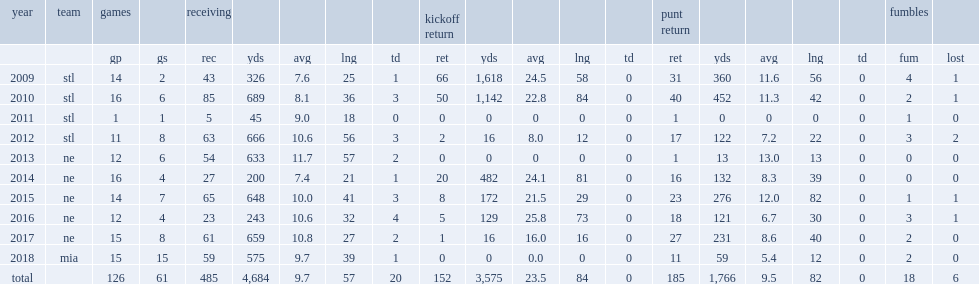In 2016, how many yards did amendola finish with? 129.0. I'm looking to parse the entire table for insights. Could you assist me with that? {'header': ['year', 'team', 'games', '', 'receiving', '', '', '', '', 'kickoff return', '', '', '', '', 'punt return', '', '', '', '', 'fumbles', ''], 'rows': [['', '', 'gp', 'gs', 'rec', 'yds', 'avg', 'lng', 'td', 'ret', 'yds', 'avg', 'lng', 'td', 'ret', 'yds', 'avg', 'lng', 'td', 'fum', 'lost'], ['2009', 'stl', '14', '2', '43', '326', '7.6', '25', '1', '66', '1,618', '24.5', '58', '0', '31', '360', '11.6', '56', '0', '4', '1'], ['2010', 'stl', '16', '6', '85', '689', '8.1', '36', '3', '50', '1,142', '22.8', '84', '0', '40', '452', '11.3', '42', '0', '2', '1'], ['2011', 'stl', '1', '1', '5', '45', '9.0', '18', '0', '0', '0', '0', '0', '0', '1', '0', '0', '0', '0', '1', '0'], ['2012', 'stl', '11', '8', '63', '666', '10.6', '56', '3', '2', '16', '8.0', '12', '0', '17', '122', '7.2', '22', '0', '3', '2'], ['2013', 'ne', '12', '6', '54', '633', '11.7', '57', '2', '0', '0', '0', '0', '0', '1', '13', '13.0', '13', '0', '0', '0'], ['2014', 'ne', '16', '4', '27', '200', '7.4', '21', '1', '20', '482', '24.1', '81', '0', '16', '132', '8.3', '39', '0', '0', '0'], ['2015', 'ne', '14', '7', '65', '648', '10.0', '41', '3', '8', '172', '21.5', '29', '0', '23', '276', '12.0', '82', '0', '1', '1'], ['2016', 'ne', '12', '4', '23', '243', '10.6', '32', '4', '5', '129', '25.8', '73', '0', '18', '121', '6.7', '30', '0', '3', '1'], ['2017', 'ne', '15', '8', '61', '659', '10.8', '27', '2', '1', '16', '16.0', '16', '0', '27', '231', '8.6', '40', '0', '2', '0'], ['2018', 'mia', '15', '15', '59', '575', '9.7', '39', '1', '0', '0', '0.0', '0', '0', '11', '59', '5.4', '12', '0', '2', '0'], ['total', '', '126', '61', '485', '4,684', '9.7', '57', '20', '152', '3,575', '23.5', '84', '0', '185', '1,766', '9.5', '82', '0', '18', '6']]} 